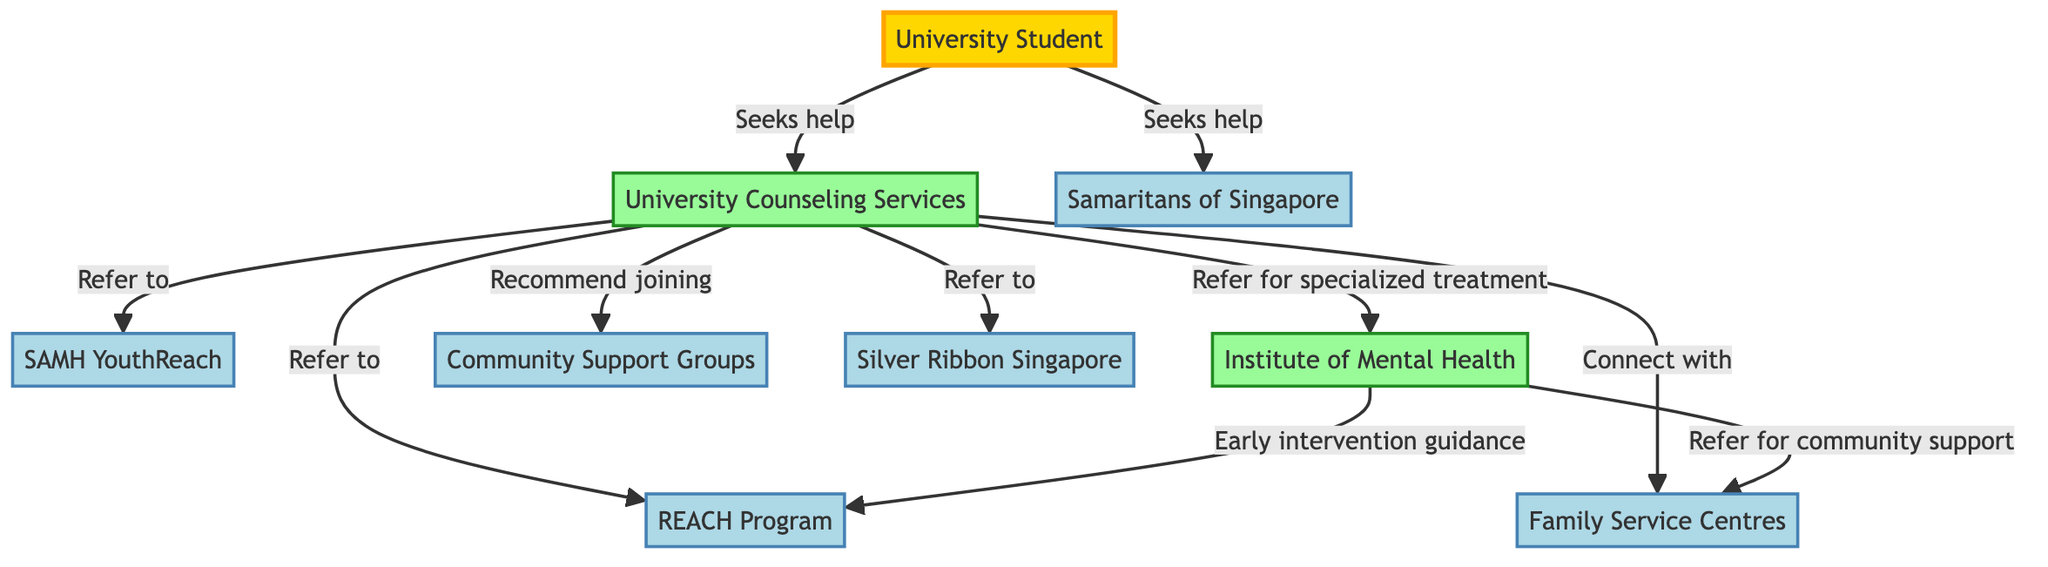What is the total number of nodes in the diagram? The diagram has 9 nodes, which are University Student, University Counseling Services, SAMH YouthReach, REACH Program, Institute of Mental Health, Community Support Groups, Family Service Centres, Silver Ribbon Singapore, and Samaritans of Singapore.
Answer: 9 Which node refers to the Institute of Mental Health for specialized treatment? The arrow points from University Counseling Services to Institute of Mental Health, indicating that it is the node that refers to the Institute of Mental Health for specialized treatment.
Answer: University Counseling Services What relationship does the University Student have with Samaritans of Singapore? The University Student seeks help from the Samaritans of Singapore, as expressed by the directed edge labeled "Seeks help" pointing from the University Student to Samaritans of Singapore.
Answer: Seeks help How many unique referral paths are there from University Counseling Services? There are 6 unique referral paths stemming from University Counseling Services, leading to the Institute of Mental Health, SAMH YouthReach, Community Support Groups, REACH Program, Family Service Centres, and Silver Ribbon Singapore.
Answer: 6 From which node does the REACH Program receive early intervention guidance? The REACH Program receives early intervention guidance from the Institute of Mental Health, as indicated by the directed edge connecting these two nodes.
Answer: Institute of Mental Health What is the connection between Family Service Centres and Community Support Groups? There is no direct connection between Family Service Centres and Community Support Groups in the diagram. However, both are nodes connected to the University Counseling Services.
Answer: No direct connection Which node is recommended for joining community support groups? The diagram shows that University Counseling Services recommends joining Community Support Groups based on the directed edge indicating the recommendation.
Answer: Community Support Groups How does the University Student connect to the mental health resources? The University Student connects to mental health resources by seeking help, as indicated by the arrows pointing from the University Student to University Counseling Services and Samaritans of Singapore.
Answer: Seeks help 